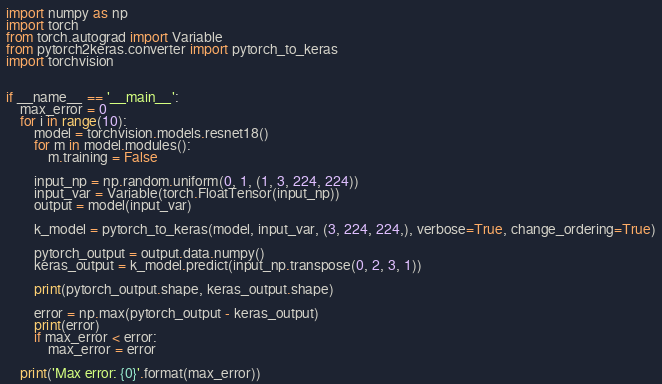<code> <loc_0><loc_0><loc_500><loc_500><_Python_>import numpy as np
import torch
from torch.autograd import Variable
from pytorch2keras.converter import pytorch_to_keras
import torchvision


if __name__ == '__main__':
    max_error = 0
    for i in range(10):
        model = torchvision.models.resnet18()
        for m in model.modules():
            m.training = False

        input_np = np.random.uniform(0, 1, (1, 3, 224, 224))
        input_var = Variable(torch.FloatTensor(input_np))
        output = model(input_var)

        k_model = pytorch_to_keras(model, input_var, (3, 224, 224,), verbose=True, change_ordering=True)

        pytorch_output = output.data.numpy()
        keras_output = k_model.predict(input_np.transpose(0, 2, 3, 1))

        print(pytorch_output.shape, keras_output.shape)

        error = np.max(pytorch_output - keras_output)
        print(error)
        if max_error < error:
            max_error = error

    print('Max error: {0}'.format(max_error))
</code> 